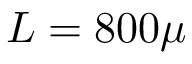Convert formula to latex. <formula><loc_0><loc_0><loc_500><loc_500>L = 8 0 0 \mu</formula> 